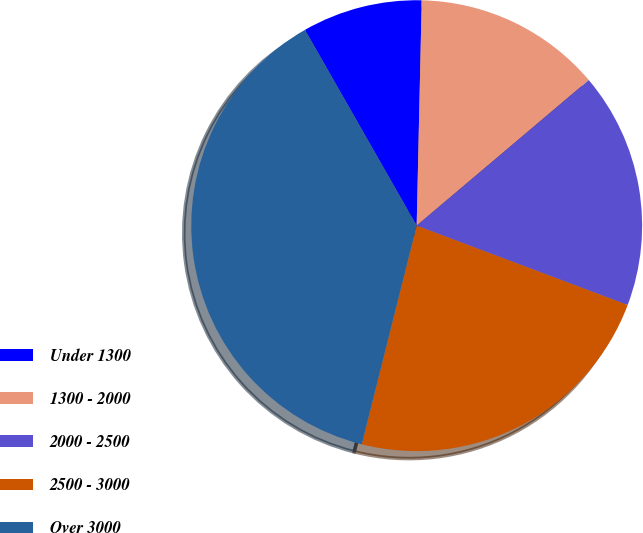Convert chart. <chart><loc_0><loc_0><loc_500><loc_500><pie_chart><fcel>Under 1300<fcel>1300 - 2000<fcel>2000 - 2500<fcel>2500 - 3000<fcel>Over 3000<nl><fcel>8.61%<fcel>13.47%<fcel>16.9%<fcel>23.19%<fcel>37.83%<nl></chart> 